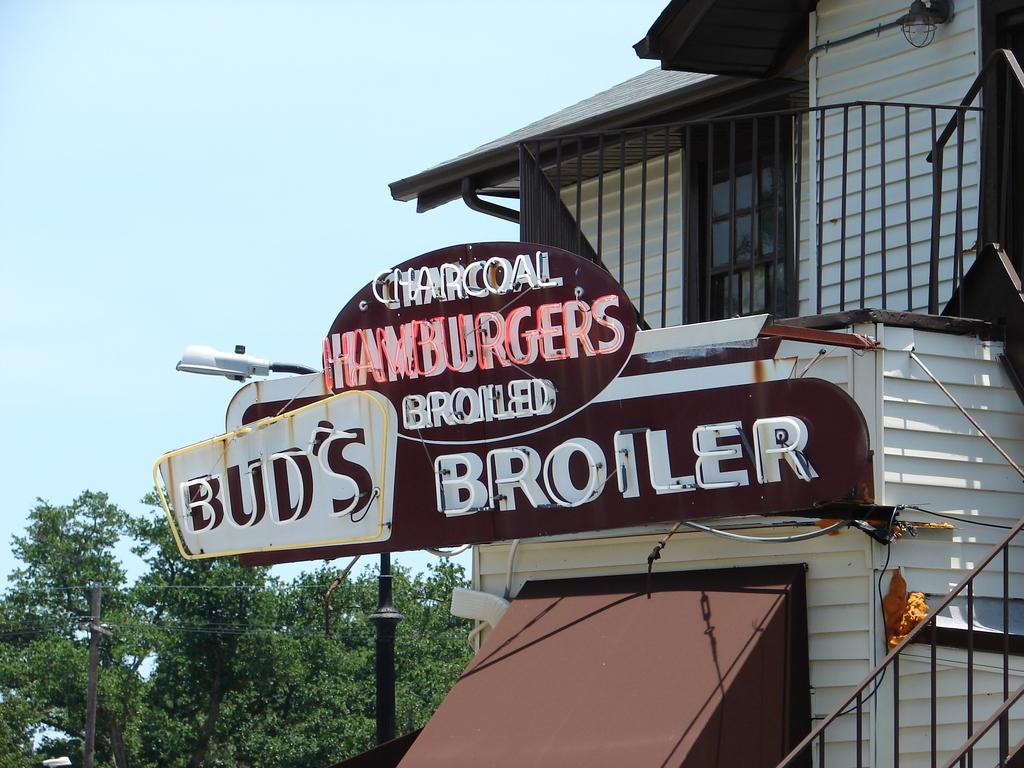What type of establishment is shown in the image? The image depicts a cafe. How can the name of the cafe be identified in the image? The name of the cafe is displayed on boards in the front. What natural elements are present near the cafe? There are trees beside the cafe. What utility features are present near the cafe? There is a current pole and a street light near the cafe. How many legs does the cave have in the image? There is no cave present in the image, so it cannot be determined how many legs it might have. What type of paper is being used to write the menu in the image? There is no paper visible in the image, as the menu is displayed on boards. 